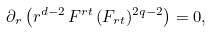<formula> <loc_0><loc_0><loc_500><loc_500>\partial _ { r } \left ( r ^ { d - 2 } \, F ^ { r t } \, ( F _ { r t } ) ^ { 2 q - 2 } \right ) = 0 ,</formula> 